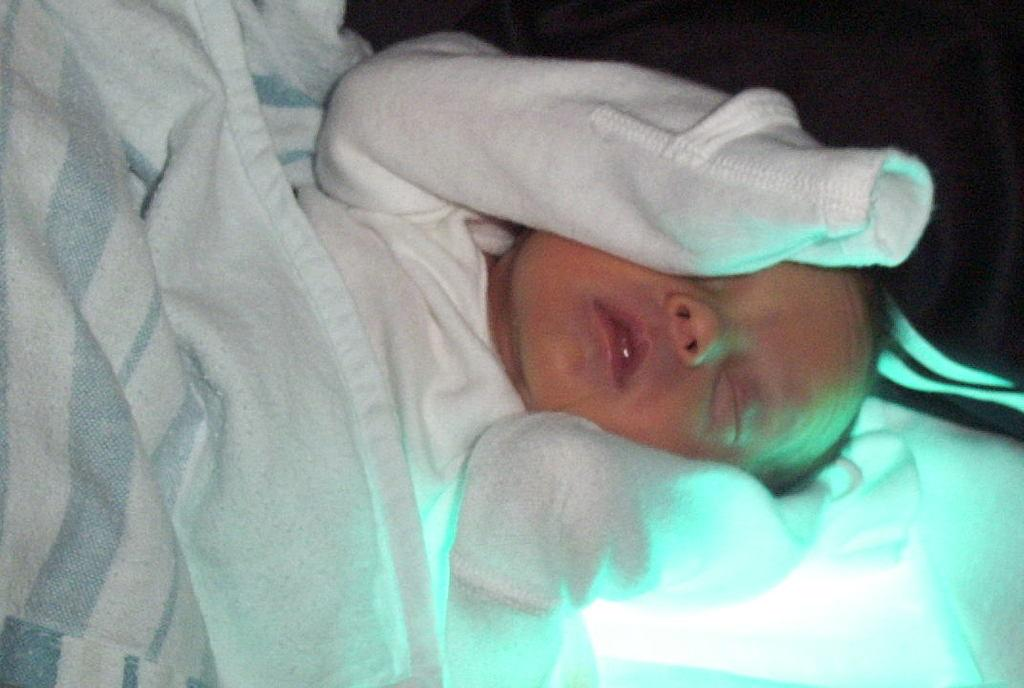What is the main subject of the image? The main subject of the image is a baby. What else can be seen in the image besides the baby? There are clothes visible in the image. Can you describe the background of the image? The background of the image is dark. What type of glove is the baby wearing in the image? There is no glove visible in the image; the baby is not wearing any gloves. 